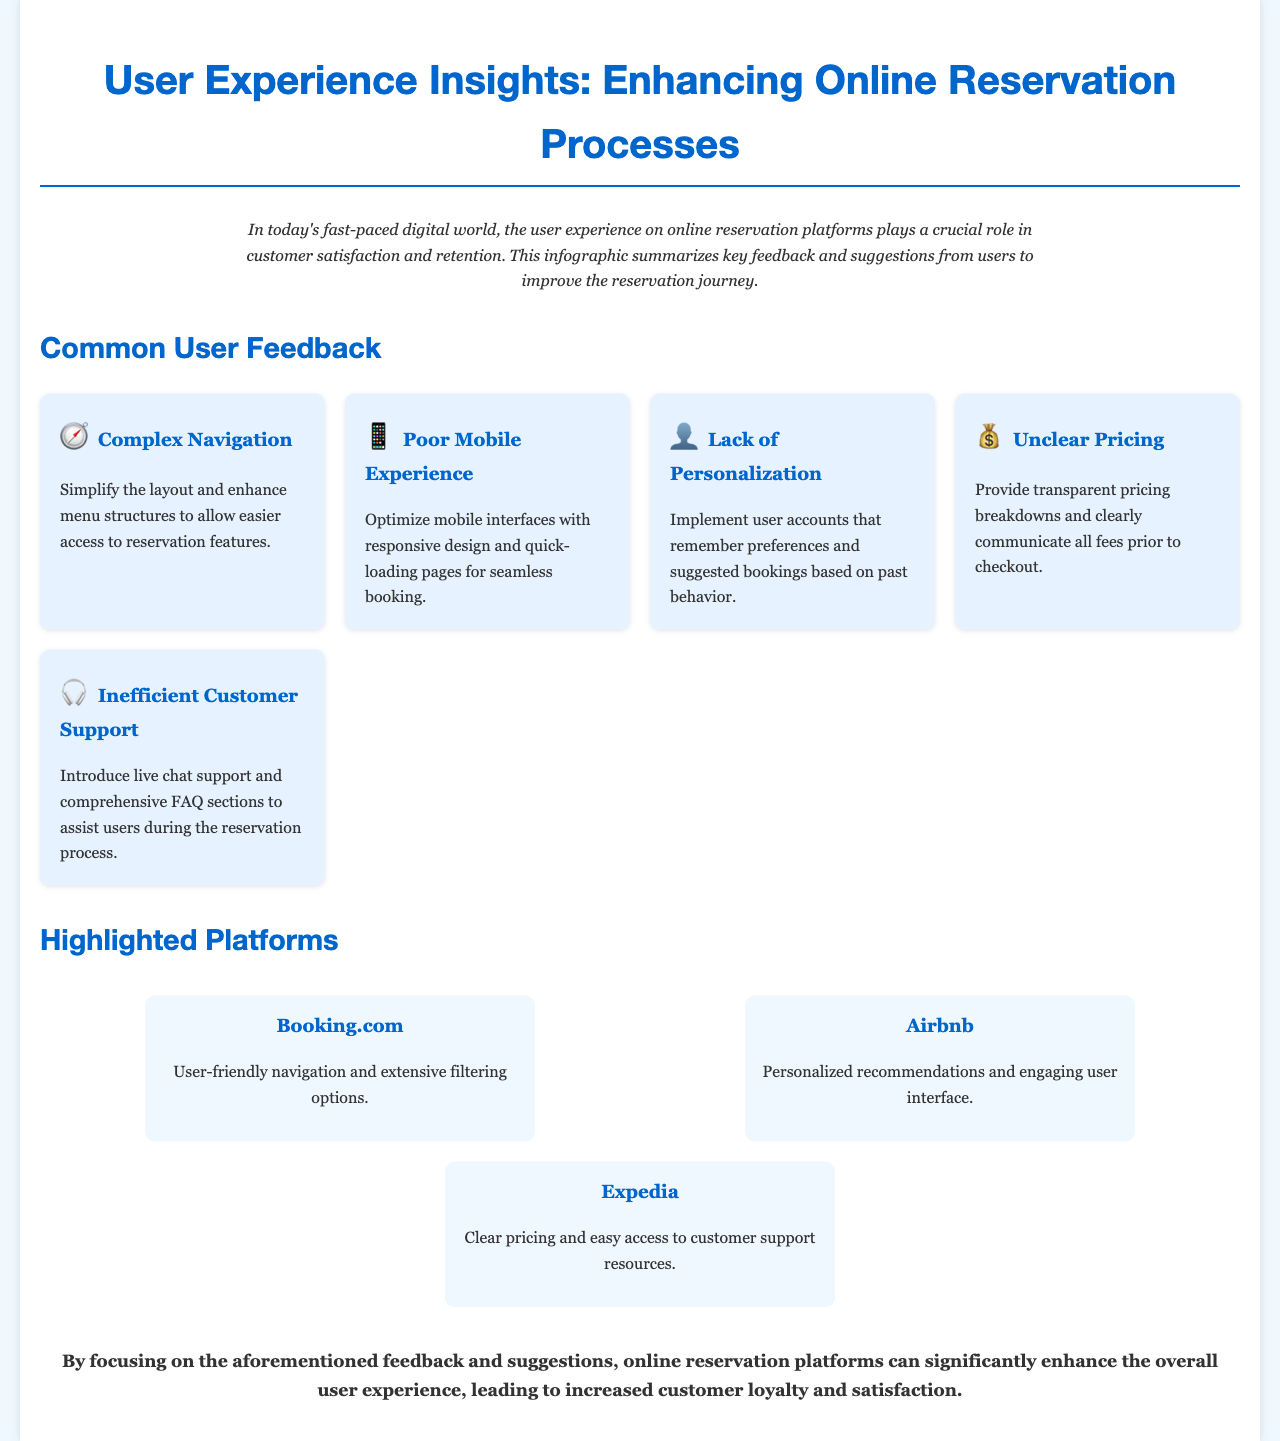What is the title of the document? The title is specified in the document's header section.
Answer: User Experience Insights: Enhancing Online Reservation Processes How many common user feedback points are listed? The number of feedback points is indicated in the section discussing common user feedback.
Answer: Five Which platform is highlighted for its user-friendly navigation? The platforms and their characteristics are detailed in the highlighted platforms section.
Answer: Booking.com What suggestion is made regarding mobile experience? The feedback grid outlines suggestions for improving specific issues.
Answer: Optimize mobile interfaces What is the icon representing complex navigation? Each feedback point is accompanied by an icon.
Answer: 🧭 What aspect of customer service is suggested to improve? The document mentions specific improvements in customer support throughout the text.
Answer: Introduce live chat support Which platform provides clear pricing? This is one of the highlighted platforms noted for a specific quality.
Answer: Expedia What is mentioned about pricing transparency? The feedback grid discusses various user concerns.
Answer: Provide transparent pricing breakdowns What is the conclusion's main focus? The conclusion summarizes the overall message of the document based on the feedback provided.
Answer: Enhance overall user experience 